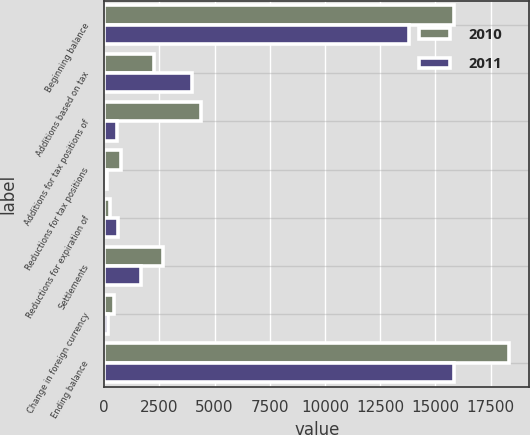Convert chart. <chart><loc_0><loc_0><loc_500><loc_500><stacked_bar_chart><ecel><fcel>Beginning balance<fcel>Additions based on tax<fcel>Additions for tax positions of<fcel>Reductions for tax positions<fcel>Reductions for expiration of<fcel>Settlements<fcel>Change in foreign currency<fcel>Ending balance<nl><fcel>2010<fcel>15824<fcel>2269<fcel>4375<fcel>746<fcel>269<fcel>2661<fcel>447<fcel>18345<nl><fcel>2011<fcel>13804<fcel>3999<fcel>592<fcel>137<fcel>610<fcel>1668<fcel>156<fcel>15824<nl></chart> 